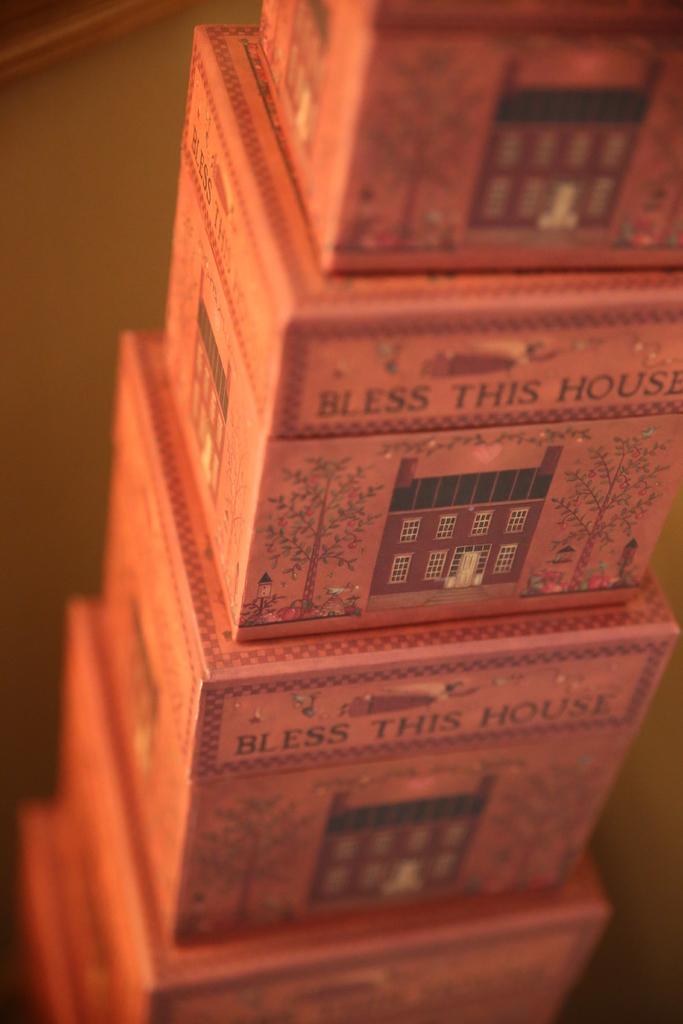What should you do to this house?
Provide a succinct answer. Bless. 